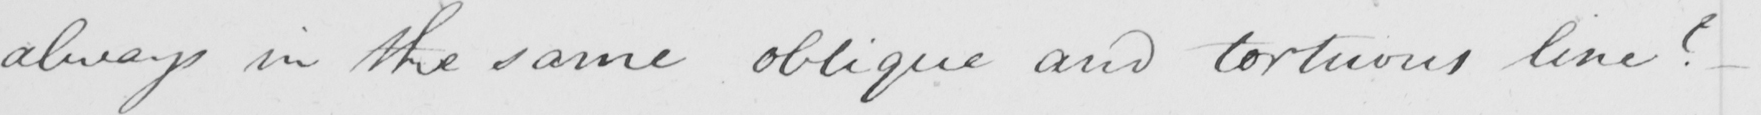What text is written in this handwritten line? always in the same oblique and tortuous line  _ 